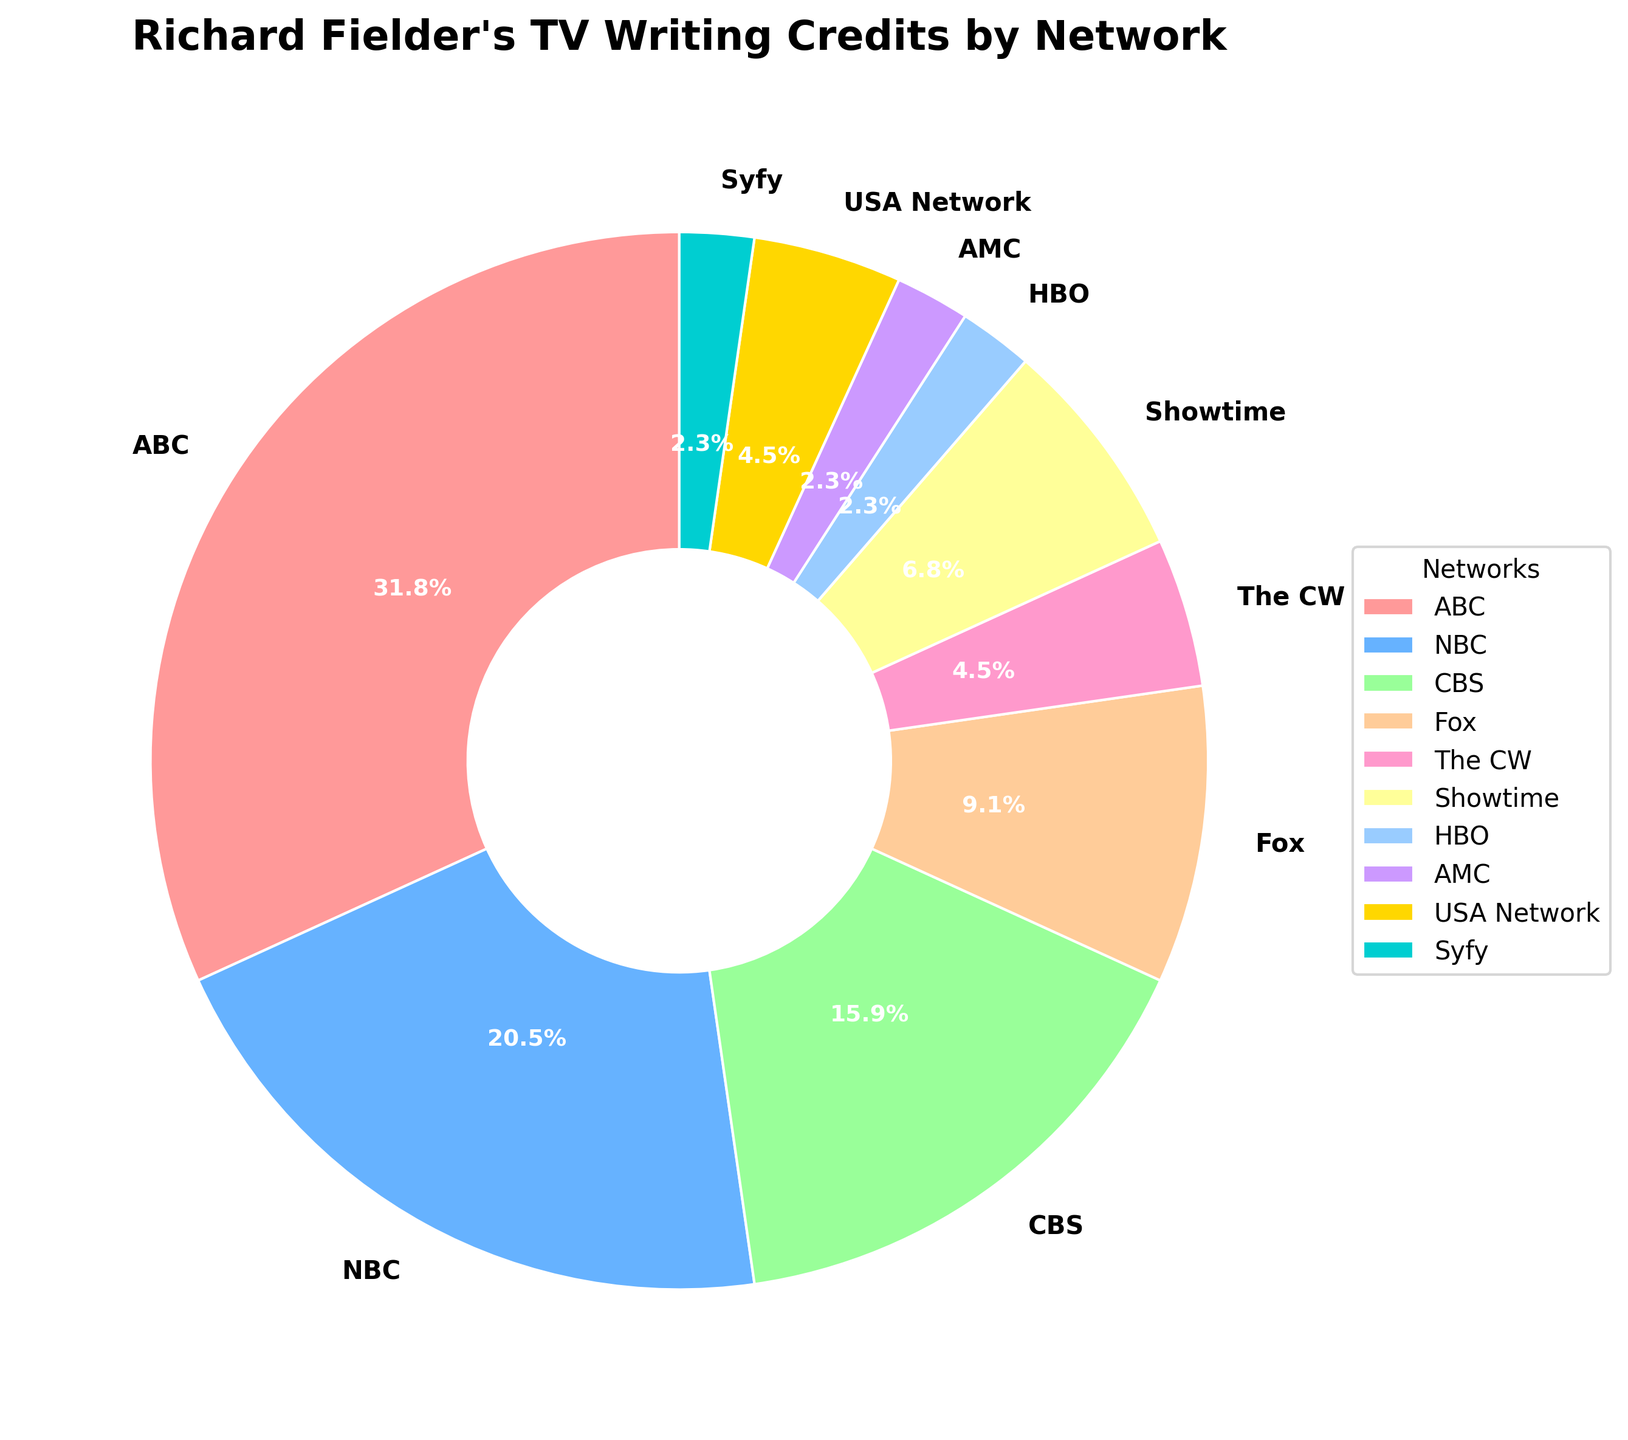Which network has the highest number of credits? The wedge with the largest area in the pie chart corresponds to ABC, and the label indicates it has 14 credits, which is the highest among all networks.
Answer: ABC Which two networks combined make up 50% of Richard Fielder's credits? Look for the percentages in each slice. ABC (14 credits) covers 42.4%, and NBC (9 credits) covers 27.3%. Combined, they contribute 69.7%, which is more than 50% alone. On the other hand, ABC (42.4%) and CBS (7 credits, 21.2%) together make up 63.6%, which is more than 50%. So the answer should involve further breaking down. ABC’s 42.4% requires an additional CBS (21.2%).
Answer: ABC and CBS How many networks does Richard Fielder have more than 5 credits with? Look at the pie chart labels. ABC (14 credits), NBC (9 credits), and CBS (7 credits) each have more than 5 credits. Therefore, the answer is 3.
Answer: 3 Which network has exactly one writing credit? The pie chart shows specific labels for HBO and AMC, each having one credit.
Answer: HBO and AMC What is the total percentage of credits that belongs to networks with more than 7 credits? ABC (14 credits) and NBC (9 credits) both have more than 7 credits. Their percentages are 42.4% and 27.3%, respectively. Adding these gives 42.4% + 27.3% = 69.7%.
Answer: 69.7% What percentage of Richard Fielder's credits are with Showtime? Showtime’s slice in the pie chart is labeled with its percentage, which is 3 credits out of the total.
Answer: 9.1% Which network does Richard Fielder have fewer credits with: Fox or Showtime? The number of credits for Fox is 4 and for Showtime is 3. Since 3 is less than 4, the network with fewer credits is Showtime.
Answer: Showtime What is the difference in the percentage of credits between ABC and NBC? ABC's percentage is 42.4% and NBC's percentage is 27.3%. The difference is calculated as 42.4% - 27.3% = 15.1%.
Answer: 15.1% What is the total number of networks represented in the chart? Count all the network labels in the pie chart: ABC, NBC, CBS, Fox, The CW, Showtime, HBO, AMC, USA Network, and Syfy. There are 10 networks in total.
Answer: 10 Compare the credit distribution between Fox and USA Network. Which one has more and by what amount? Fox has 4 credits and USA Network has 2 credits. The difference between them is 4 - 2 = 2 credits. So, Fox has 2 more credits.
Answer: Fox by 2 